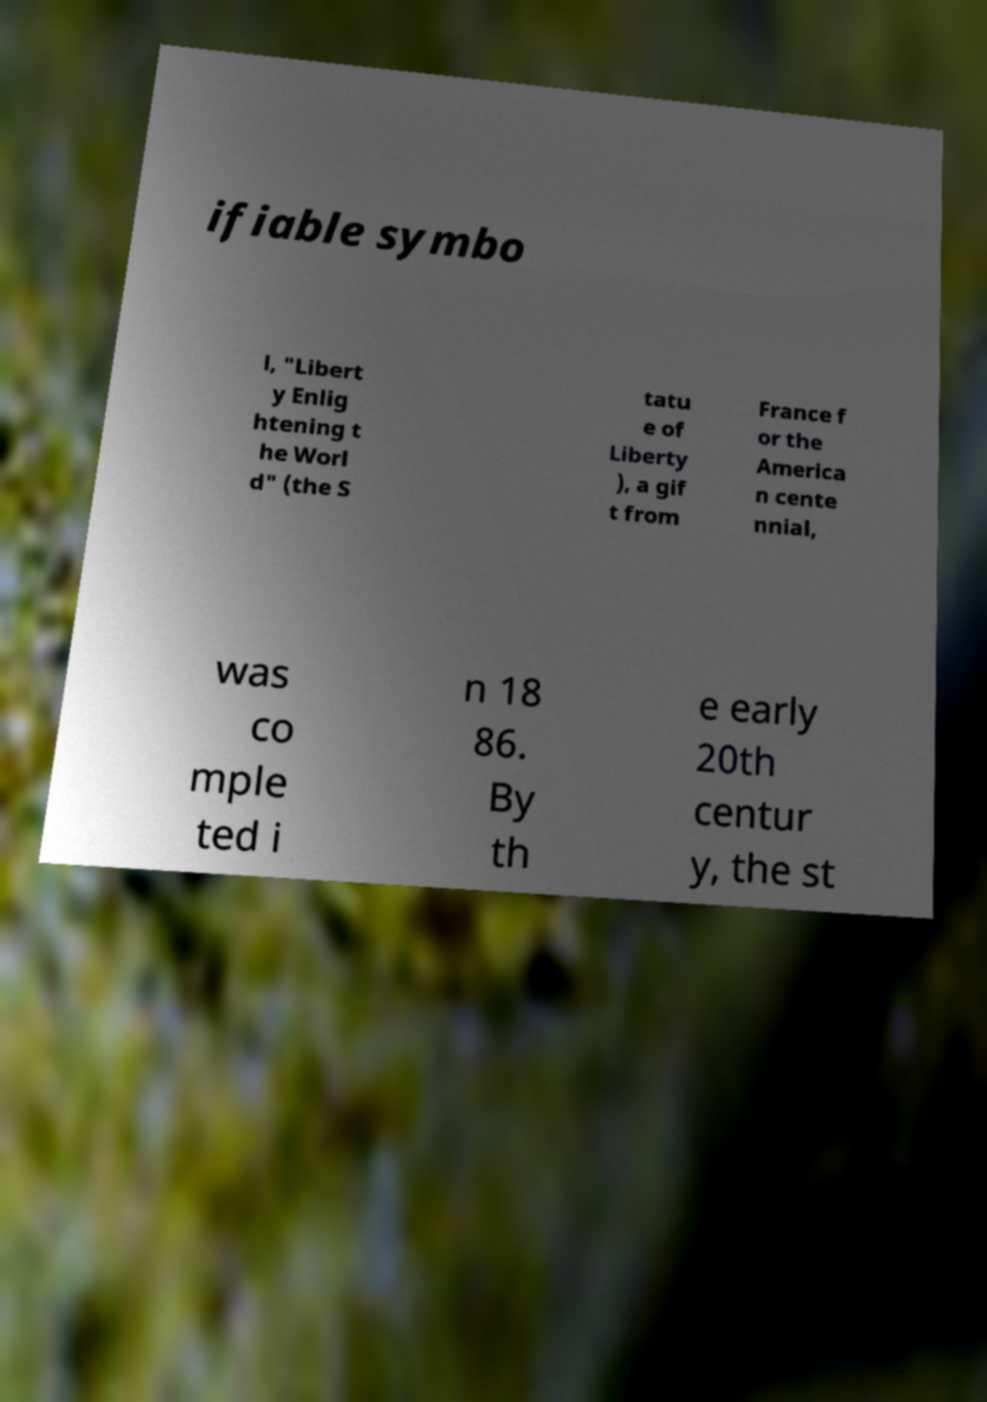Could you assist in decoding the text presented in this image and type it out clearly? ifiable symbo l, "Libert y Enlig htening t he Worl d" (the S tatu e of Liberty ), a gif t from France f or the America n cente nnial, was co mple ted i n 18 86. By th e early 20th centur y, the st 